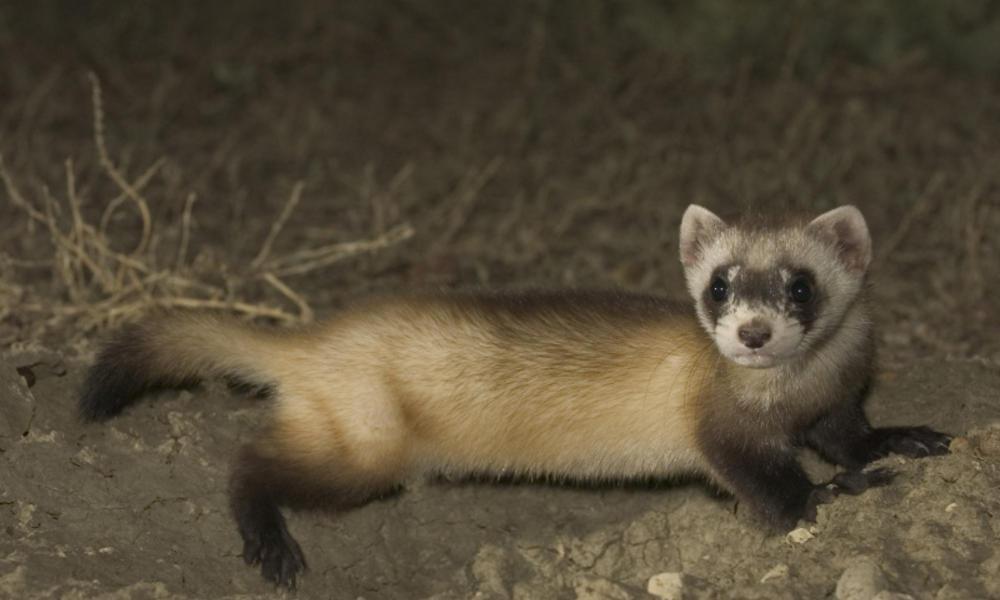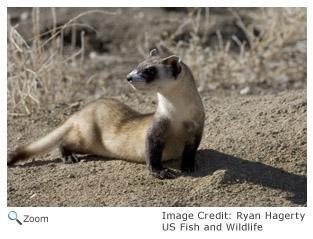The first image is the image on the left, the second image is the image on the right. Evaluate the accuracy of this statement regarding the images: "The animal in one of the images is in side profile". Is it true? Answer yes or no. Yes. 